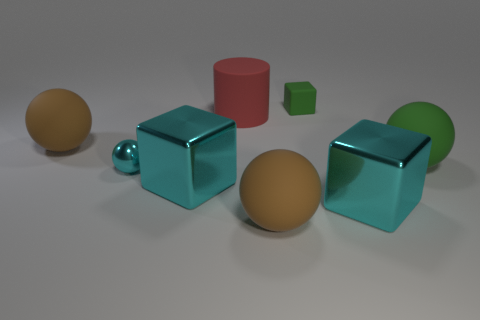Subtract all green cubes. How many cubes are left? 2 Subtract all green blocks. How many blocks are left? 2 Add 1 large green blocks. How many objects exist? 9 Subtract all brown blocks. How many brown balls are left? 2 Subtract 0 purple cylinders. How many objects are left? 8 Subtract all blocks. How many objects are left? 5 Subtract 1 spheres. How many spheres are left? 3 Subtract all brown blocks. Subtract all blue balls. How many blocks are left? 3 Subtract all small yellow objects. Subtract all green things. How many objects are left? 6 Add 6 large rubber cylinders. How many large rubber cylinders are left? 7 